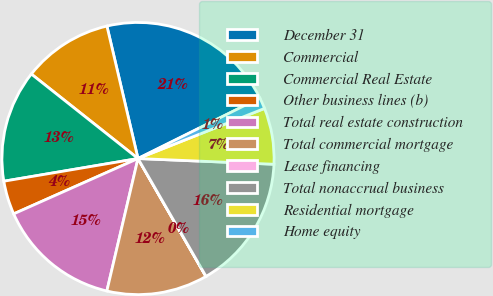Convert chart. <chart><loc_0><loc_0><loc_500><loc_500><pie_chart><fcel>December 31<fcel>Commercial<fcel>Commercial Real Estate<fcel>Other business lines (b)<fcel>Total real estate construction<fcel>Total commercial mortgage<fcel>Lease financing<fcel>Total nonaccrual business<fcel>Residential mortgage<fcel>Home equity<nl><fcel>21.33%<fcel>10.67%<fcel>13.33%<fcel>4.0%<fcel>14.66%<fcel>12.0%<fcel>0.01%<fcel>16.0%<fcel>6.67%<fcel>1.34%<nl></chart> 